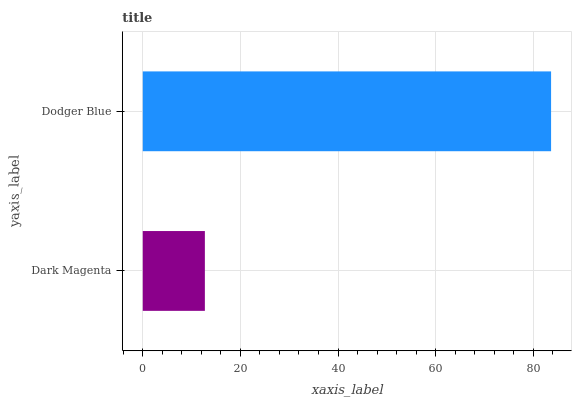Is Dark Magenta the minimum?
Answer yes or no. Yes. Is Dodger Blue the maximum?
Answer yes or no. Yes. Is Dodger Blue the minimum?
Answer yes or no. No. Is Dodger Blue greater than Dark Magenta?
Answer yes or no. Yes. Is Dark Magenta less than Dodger Blue?
Answer yes or no. Yes. Is Dark Magenta greater than Dodger Blue?
Answer yes or no. No. Is Dodger Blue less than Dark Magenta?
Answer yes or no. No. Is Dodger Blue the high median?
Answer yes or no. Yes. Is Dark Magenta the low median?
Answer yes or no. Yes. Is Dark Magenta the high median?
Answer yes or no. No. Is Dodger Blue the low median?
Answer yes or no. No. 